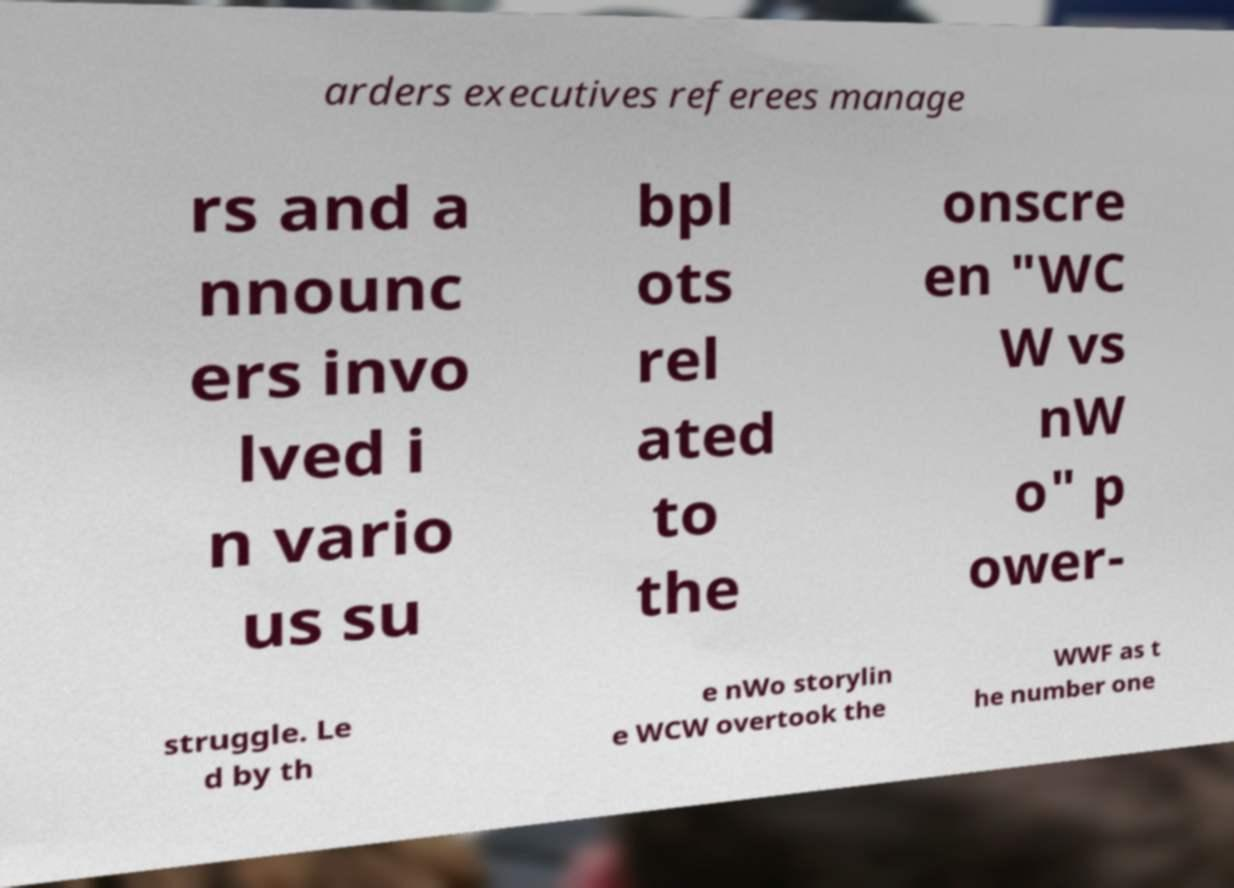Could you extract and type out the text from this image? arders executives referees manage rs and a nnounc ers invo lved i n vario us su bpl ots rel ated to the onscre en "WC W vs nW o" p ower- struggle. Le d by th e nWo storylin e WCW overtook the WWF as t he number one 